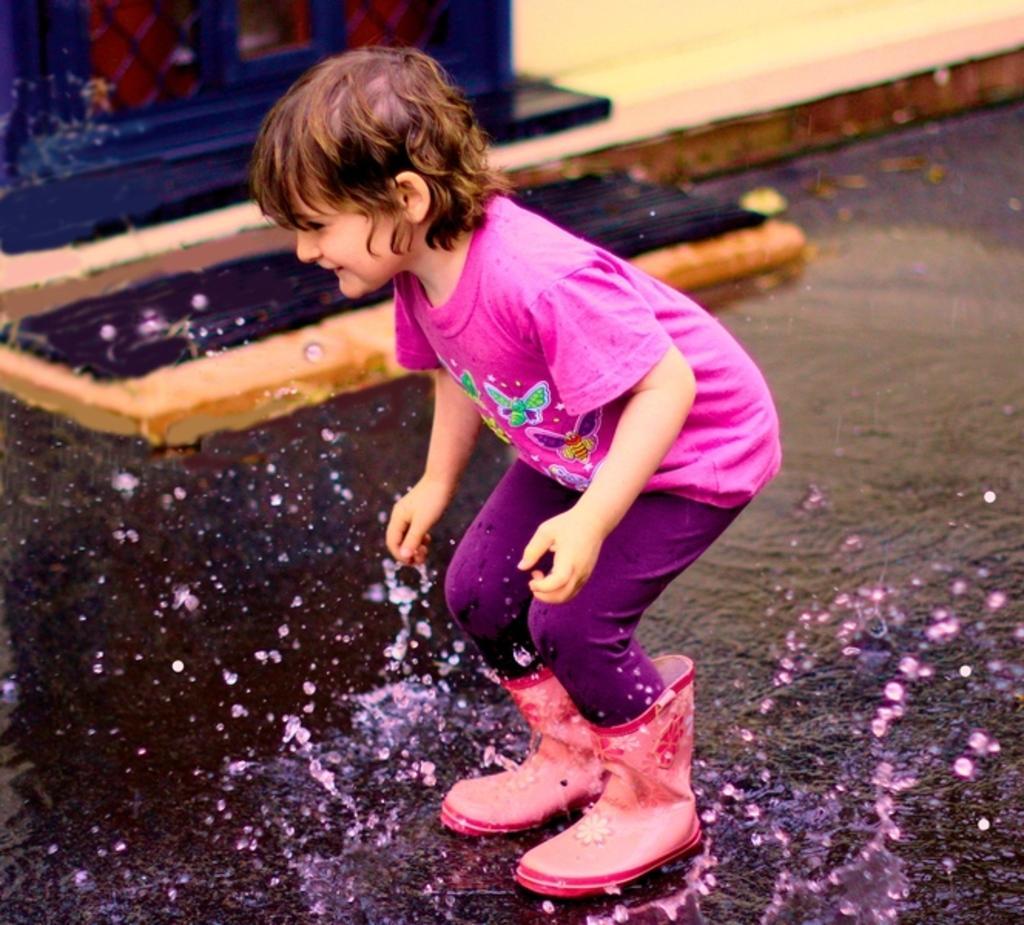Could you give a brief overview of what you see in this image? As we can see in the image there is a person wearing pink color t shirt. There is water and wall. 